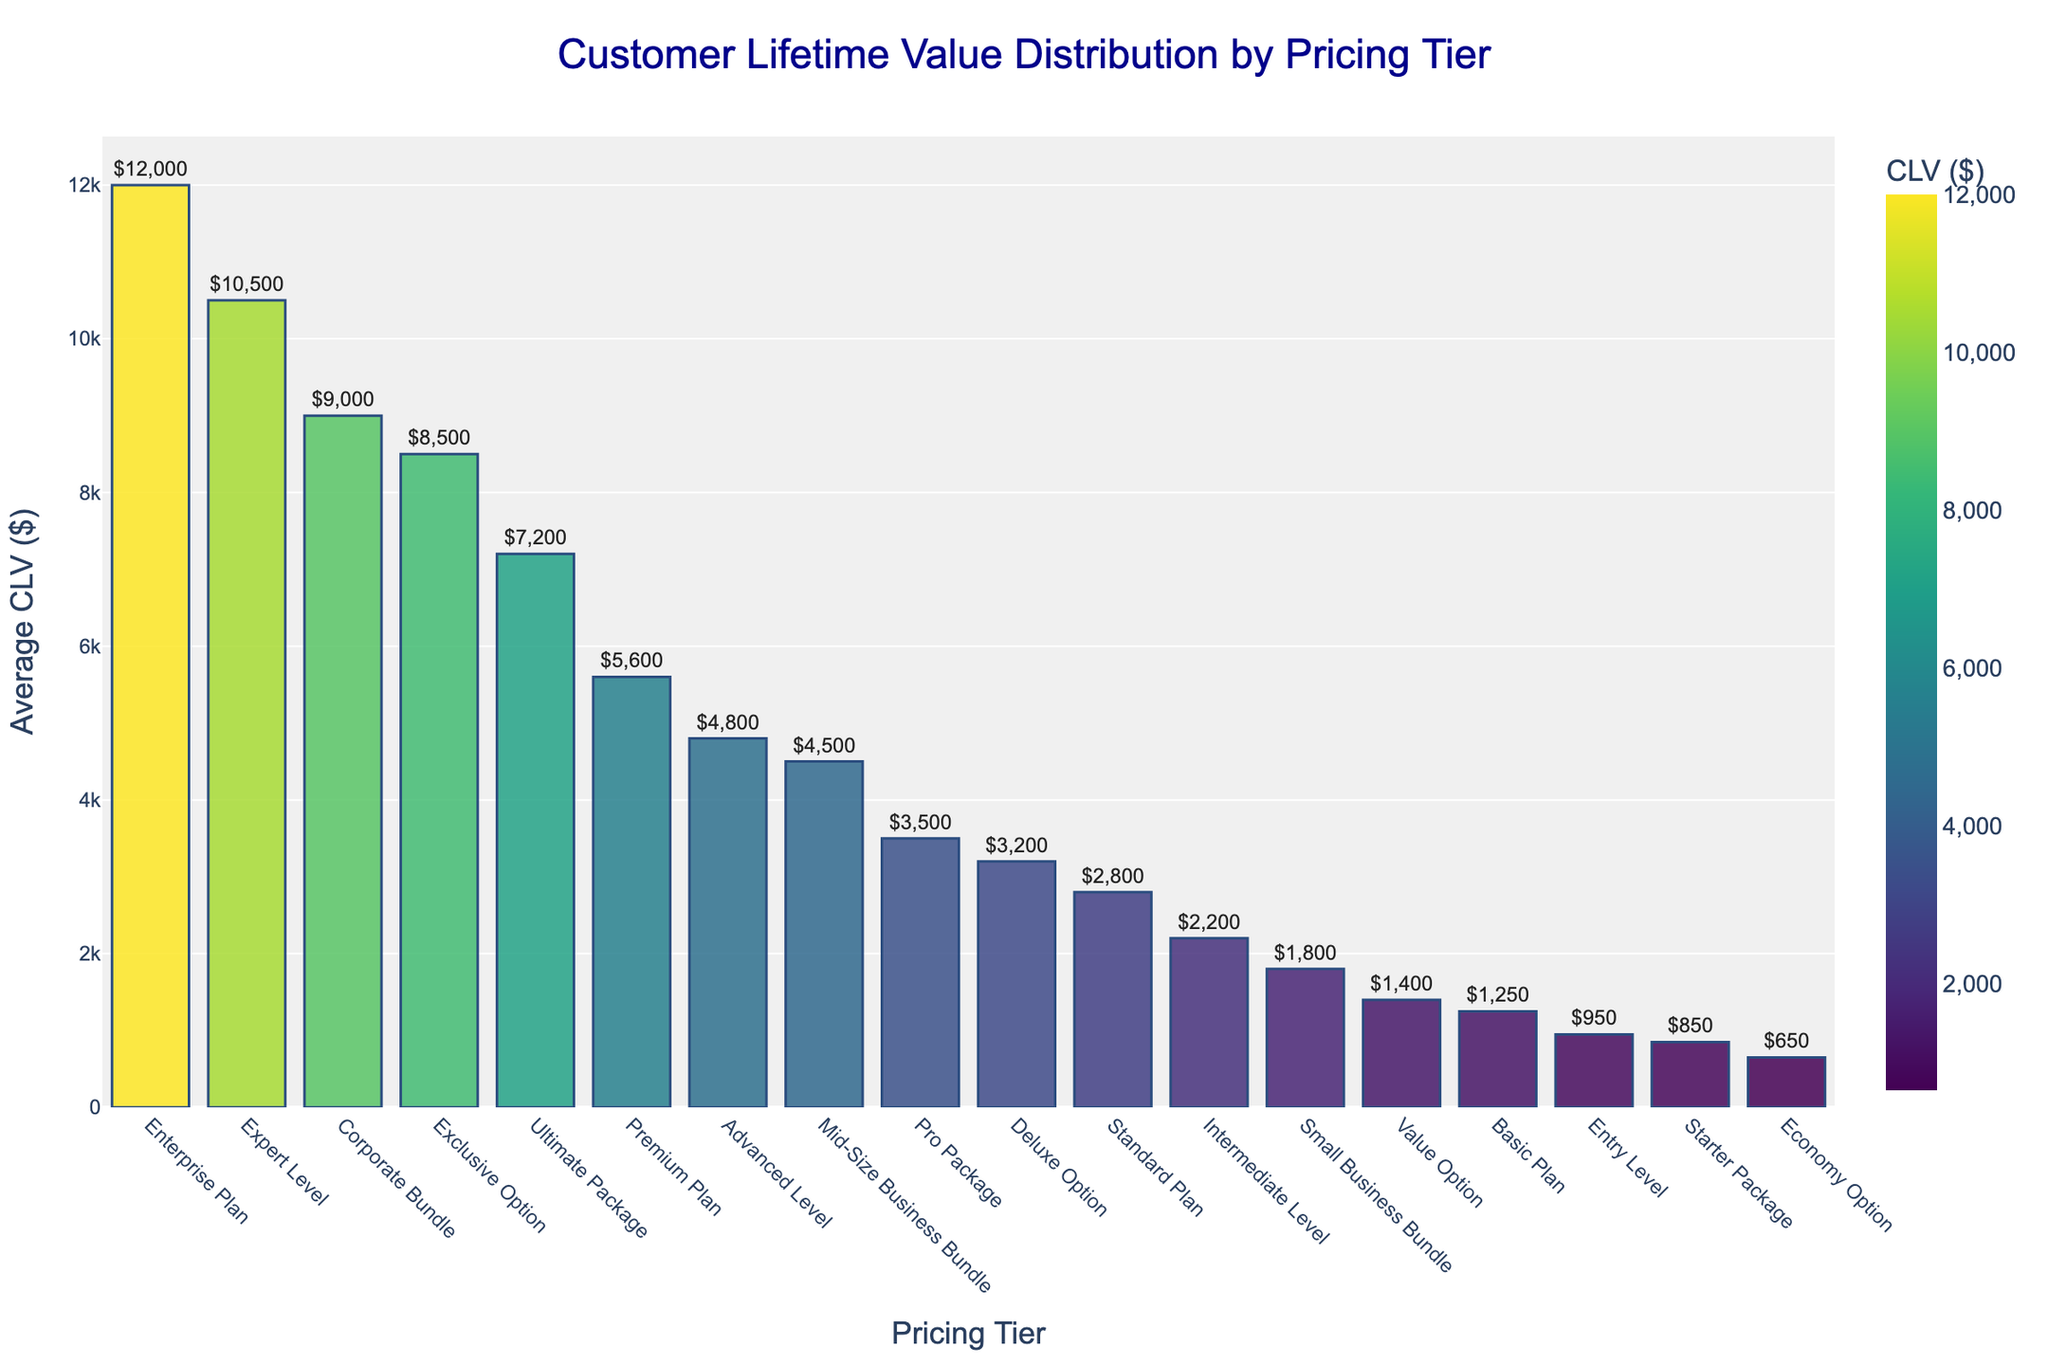What pricing tier has the highest average customer lifetime value? Look for the bar with the highest value on the y-axis in the plot. The Enterprise Plan has the tallest bar, indicating the highest average customer lifetime value.
Answer: Enterprise Plan How much more is the average customer lifetime value for the Premium Plan compared to the Deluxe Option? Find the bars for the Premium Plan and Deluxe Option. The Premium Plan has an average CLV of $5,600, while the Deluxe Option has $3,200. Subtract the two values: $5,600 - $3,200.
Answer: $2,400 Which pricing tier has a similar average customer lifetime value to the Premium Plan? Look for bars in the plot with a height similar to that of the Premium Plan ($5,600). The Advanced Level with $4,800 is visually close but not as high.
Answer: None What is the combined average customer lifetime value of the Small Business Bundle and the Mid-Size Business Bundle? Locate the bars for both tiers. The Small Business Bundle has an average CLV of $1,800, and the Mid-Size Business Bundle has $4,500. Add the two values: $1,800 + $4,500.
Answer: $6,300 How does the Customer Lifetime Value of the Corporate Bundle compare to the Expert Level? Identify the bars for Corporate Bundle and Expert Level. The Corporate Bundle has an average CLV of $9,000, while the Expert Level has $10,500. The Expert Level's bar is higher, showing a greater value.
Answer: Expert Level is higher by $1,500 What is the Customer Lifetime Value difference between the Starter Package and the Economy Option? Look for the bars representing Starter Package and Economy Option. The Starter Package has $850 and the Economy Option has $650. Subtract the smaller value from the larger value: $850 - $650.
Answer: $200 What is the average Customer Lifetime Value of all pricing tiers combined? Sum all average CLV values from the data and divide by the number of pricing tiers. (1250 + 2800 + 5600 + 12000 + 850 + 3500 + 7200 + 1800 + 4500 + 9000 + 650 + 1400 + 3200 + 8500 + 950 + 2200 + 4800 + 10500) / 18.
Answer: $4,493.33 Which pricing tier has a lower average customer lifetime value, the Basic Plan or Intermediate Level? Find the bars for both Basic Plan and Intermediate Level. The Basic Plan has $1,250, and the Intermediate Level has $2,200. The Basic Plan's bar is lower.
Answer: Basic Plan What is the ratio of the average customer lifetime value of the Enterprise Plan to the Starter Package? Locate the bars for Enterprise Plan and Starter Package. Enterprise Plan has $12,000 and Starter Package has $850. Calculate the ratio: $12,000 / $850.
Answer: 14.12 Is the average customer lifetime value of the Value Option greater than the Entry Level? Identify the bars for Value Option and Entry Level. The Value Option has $1,400, and the Entry Level has $950. The bar for Value Option is taller.
Answer: Yes 